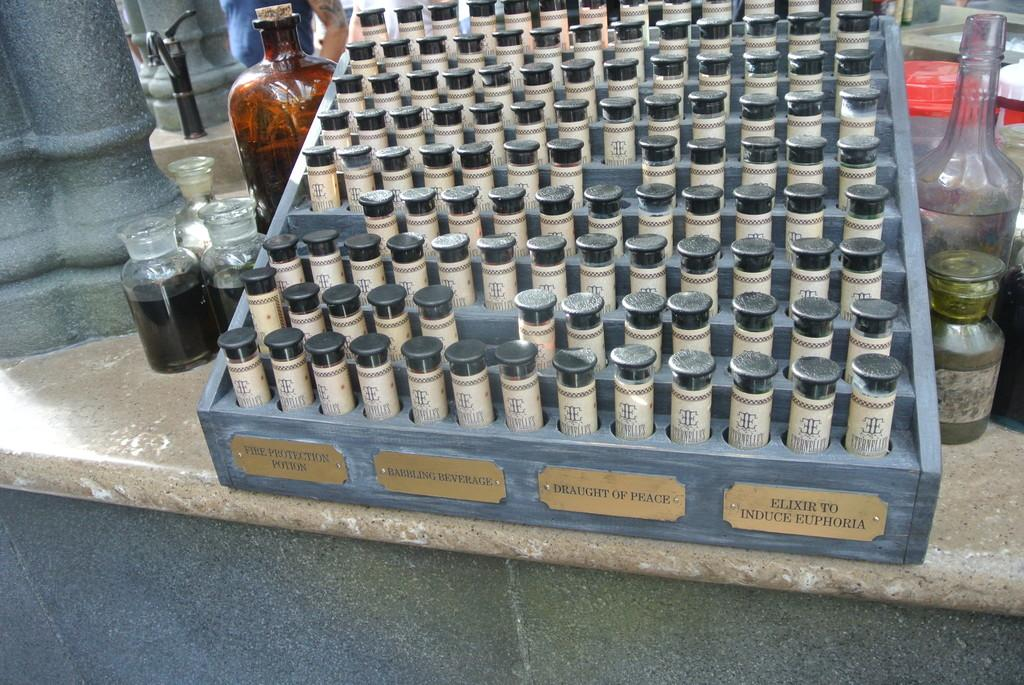<image>
Present a compact description of the photo's key features. A case of small bottles that contain healing oils with one called Draught of Peace. 